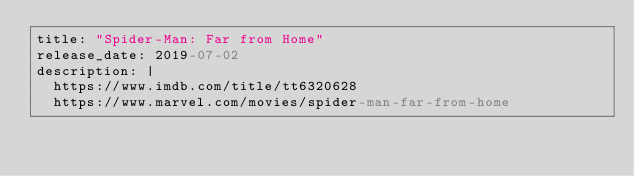<code> <loc_0><loc_0><loc_500><loc_500><_YAML_>title: "Spider-Man: Far from Home"
release_date: 2019-07-02
description: |
  https://www.imdb.com/title/tt6320628
  https://www.marvel.com/movies/spider-man-far-from-home
</code> 